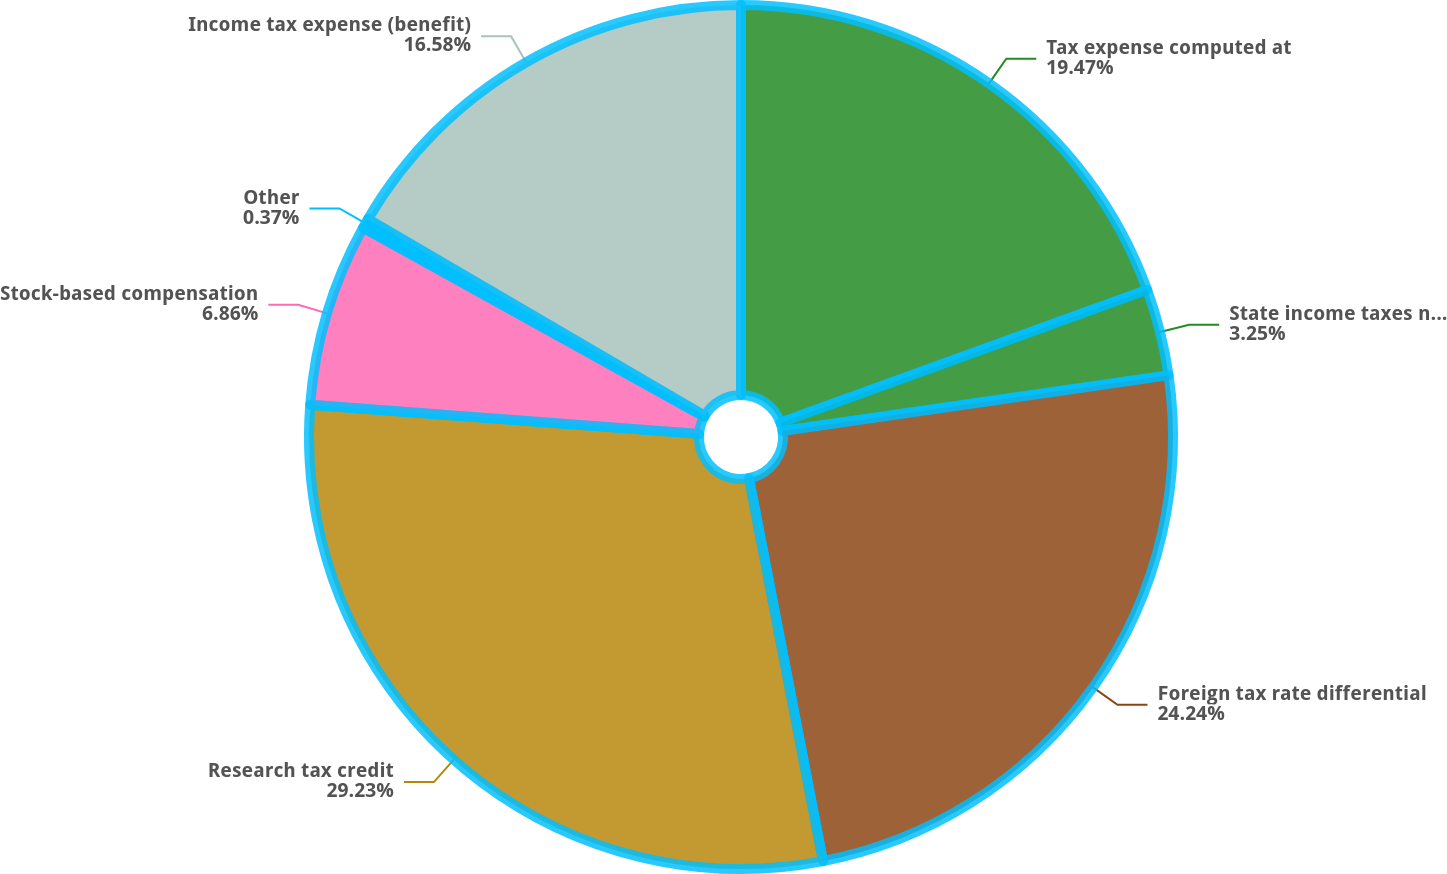<chart> <loc_0><loc_0><loc_500><loc_500><pie_chart><fcel>Tax expense computed at<fcel>State income taxes net of<fcel>Foreign tax rate differential<fcel>Research tax credit<fcel>Stock-based compensation<fcel>Other<fcel>Income tax expense (benefit)<nl><fcel>19.47%<fcel>3.25%<fcel>24.24%<fcel>29.23%<fcel>6.86%<fcel>0.37%<fcel>16.58%<nl></chart> 